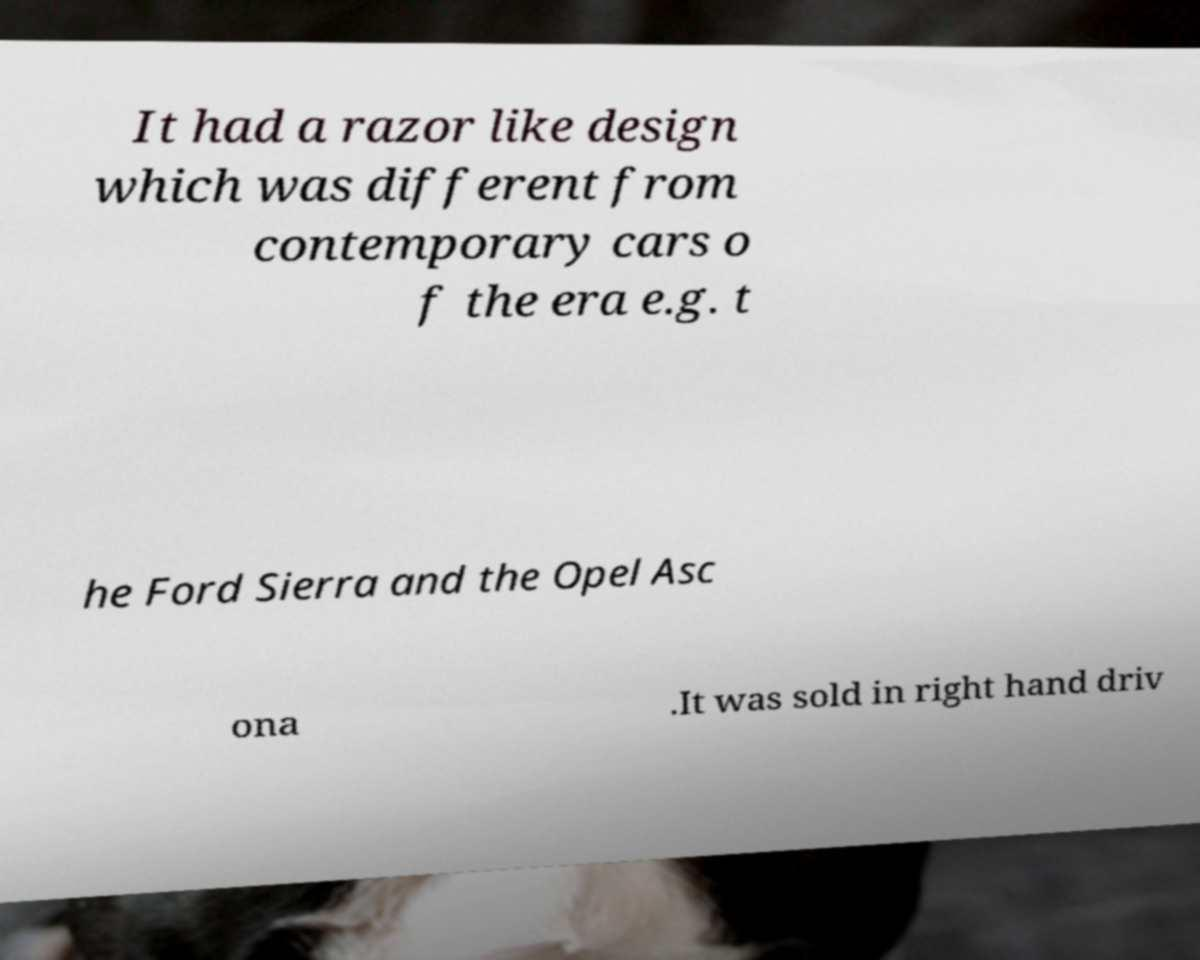Please read and relay the text visible in this image. What does it say? It had a razor like design which was different from contemporary cars o f the era e.g. t he Ford Sierra and the Opel Asc ona .It was sold in right hand driv 